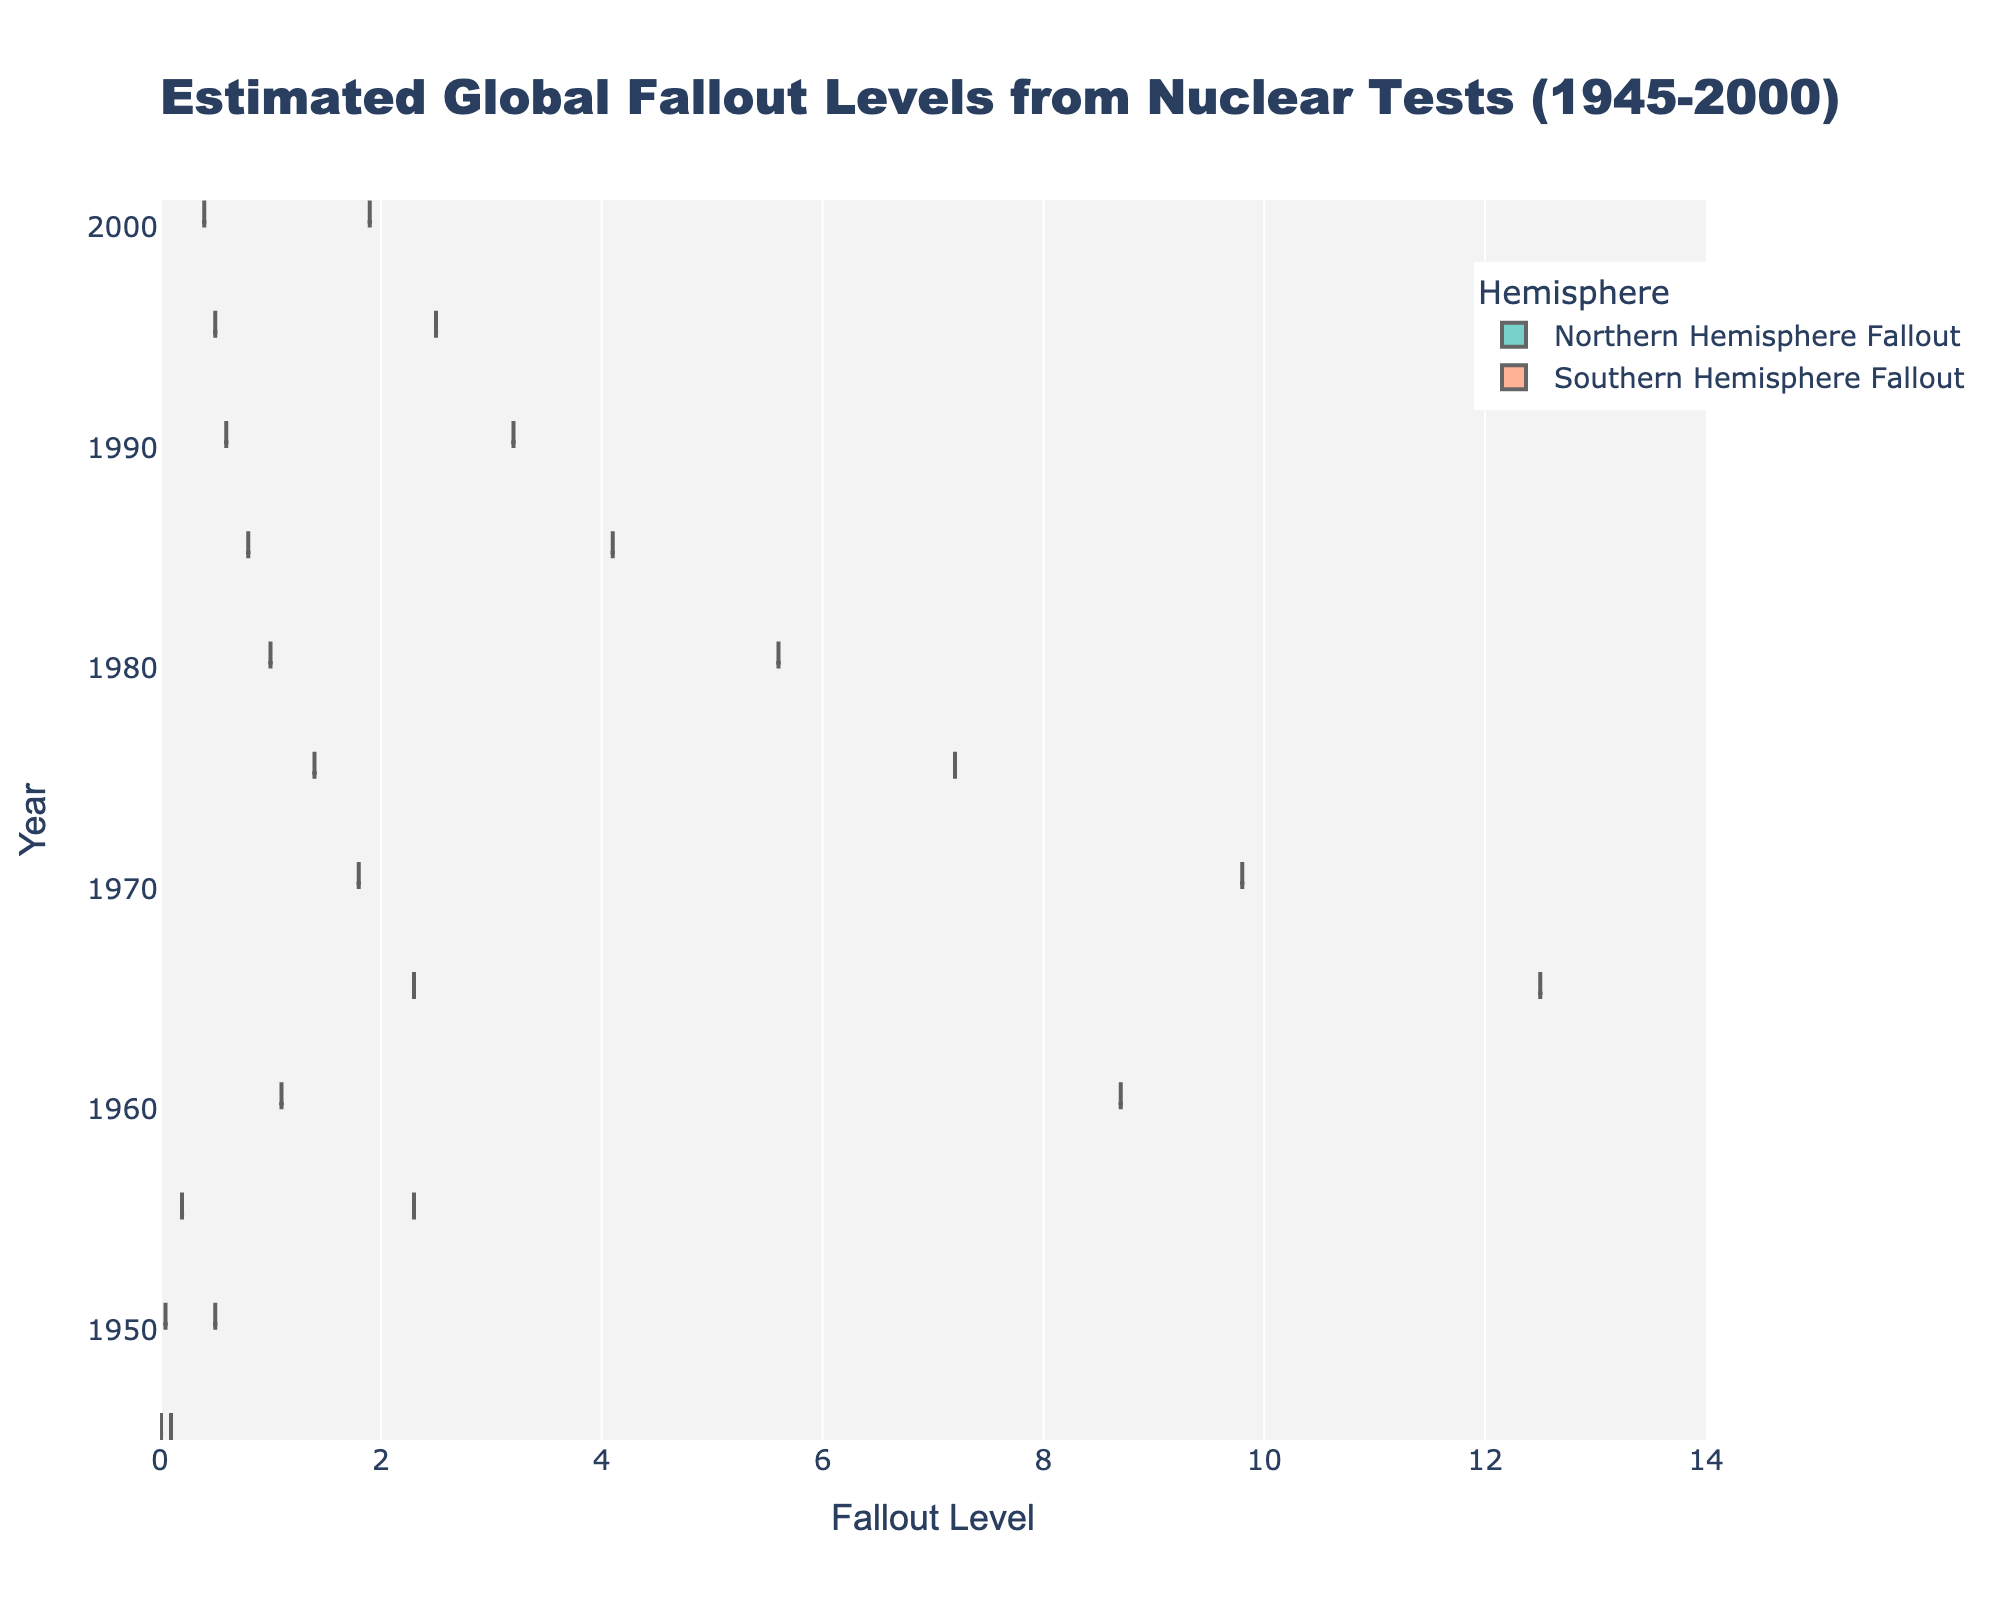What is the title of the figure? The title of the figure is displayed at the top center of the chart. It says "Estimated Global Fallout Levels from Nuclear Tests (1945-2000)."
Answer: Estimated Global Fallout Levels from Nuclear Tests (1945-2000) Which hemisphere had higher fallout levels in 1960? In 1960, the chart shows a comparison of fallout levels between the Northern Hemisphere and the Southern Hemisphere. By looking at the density plots, we see that the Northern Hemisphere had higher fallout levels.
Answer: Northern Hemisphere What is the range of fallout levels shown on the x-axis? The x-axis represents the fallout levels, with tick marks indicating the range. It starts at 0 and goes up to 14.
Answer: 0 to 14 How did the fallout levels in the Northern Hemisphere change from 1945 to 2000? By observing the density plot for the Northern Hemisphere, one can see that fallout levels started at a low value in 1945, peaked around 1965, and then gradually decreased towards 2000.
Answer: Increased, then decreased In which year did the Northern Hemisphere reach its peak fallout level? Look at the density plot for the Northern Hemisphere to identify the year with the highest peak in fallout levels, which is around 1965.
Answer: 1965 What are the mean fallout levels in the Southern Hemisphere in 1980? The Southern Hemisphere's density plot in 1980 shows the data distribution, with the mean level depicted by the mean line. Observing this line will give the approximate mean fallout level.
Answer: ~1.0 How do the mean fallout levels in the Northern Hemisphere compare to those in the Southern Hemisphere in 2000? Compare the mean lines of the density plots for both hemispheres in the year 2000. Northern Hemisphere's mean fallout is higher than that of the Southern Hemisphere.
Answer: Higher What is the box plot visible on each hemisphere's density plot? Each density plot has a box plot showing the interquartile range and median, as well as potential outliers. This helps indicate the spread of data and central tendency around each year.
Answer: Interquartile range and median Which hemisphere shows a wider spread of fallout levels over the years? Assessing the density plots for both hemispheres, the Northern Hemisphere exhibits a wider spread of fallout levels over the years compared to the Southern Hemisphere.
Answer: Northern Hemisphere What was the approximate fallout level in the Northern Hemisphere in 1970? Look at the density plot for the Northern Hemisphere around the year 1970, and check the distribution around that year. The approximate fallout level is around 9.8.
Answer: 9.8 